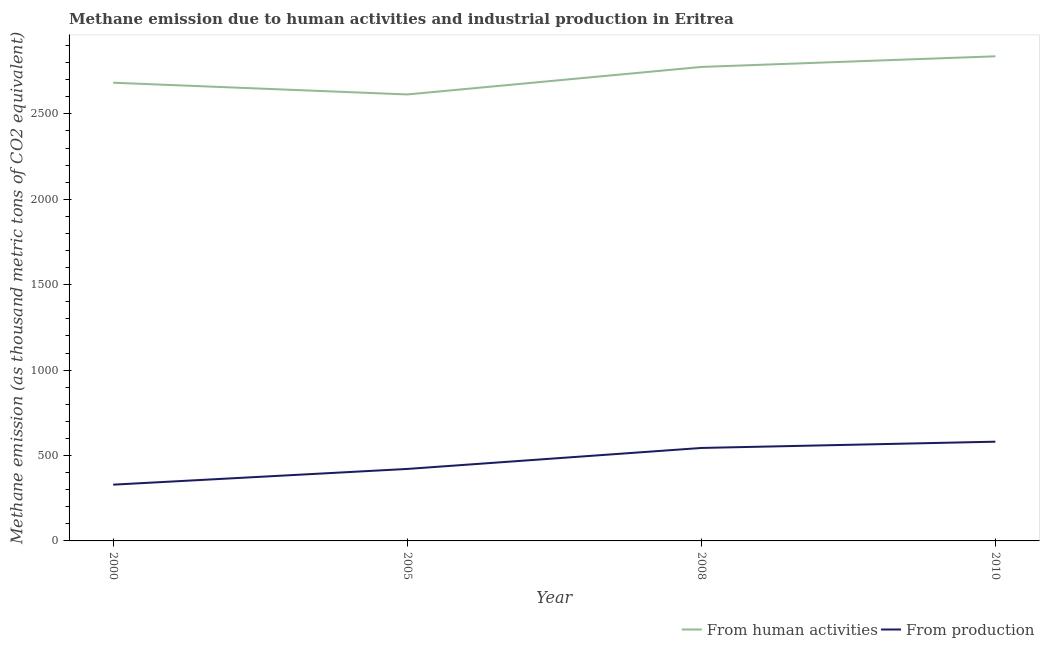How many different coloured lines are there?
Your answer should be compact. 2. Is the number of lines equal to the number of legend labels?
Your answer should be compact. Yes. What is the amount of emissions from human activities in 2010?
Give a very brief answer. 2837. Across all years, what is the maximum amount of emissions from human activities?
Keep it short and to the point. 2837. Across all years, what is the minimum amount of emissions from human activities?
Your answer should be compact. 2613.6. In which year was the amount of emissions from human activities maximum?
Provide a short and direct response. 2010. What is the total amount of emissions from human activities in the graph?
Provide a succinct answer. 1.09e+04. What is the difference between the amount of emissions generated from industries in 2005 and that in 2010?
Make the answer very short. -159.5. What is the difference between the amount of emissions generated from industries in 2010 and the amount of emissions from human activities in 2008?
Your answer should be compact. -2193.8. What is the average amount of emissions generated from industries per year?
Provide a succinct answer. 468.98. In the year 2008, what is the difference between the amount of emissions from human activities and amount of emissions generated from industries?
Provide a short and direct response. 2230.5. In how many years, is the amount of emissions from human activities greater than 1300 thousand metric tons?
Your response must be concise. 4. What is the ratio of the amount of emissions generated from industries in 2008 to that in 2010?
Keep it short and to the point. 0.94. What is the difference between the highest and the second highest amount of emissions generated from industries?
Keep it short and to the point. 36.7. What is the difference between the highest and the lowest amount of emissions from human activities?
Give a very brief answer. 223.4. In how many years, is the amount of emissions from human activities greater than the average amount of emissions from human activities taken over all years?
Offer a very short reply. 2. Is the sum of the amount of emissions generated from industries in 2005 and 2008 greater than the maximum amount of emissions from human activities across all years?
Keep it short and to the point. No. Does the amount of emissions from human activities monotonically increase over the years?
Offer a terse response. No. Is the amount of emissions generated from industries strictly less than the amount of emissions from human activities over the years?
Give a very brief answer. Yes. Does the graph contain any zero values?
Offer a terse response. No. How many legend labels are there?
Ensure brevity in your answer.  2. What is the title of the graph?
Give a very brief answer. Methane emission due to human activities and industrial production in Eritrea. What is the label or title of the X-axis?
Give a very brief answer. Year. What is the label or title of the Y-axis?
Your answer should be very brief. Methane emission (as thousand metric tons of CO2 equivalent). What is the Methane emission (as thousand metric tons of CO2 equivalent) in From human activities in 2000?
Offer a very short reply. 2682.3. What is the Methane emission (as thousand metric tons of CO2 equivalent) in From production in 2000?
Your answer should be compact. 329.4. What is the Methane emission (as thousand metric tons of CO2 equivalent) of From human activities in 2005?
Provide a succinct answer. 2613.6. What is the Methane emission (as thousand metric tons of CO2 equivalent) in From production in 2005?
Ensure brevity in your answer.  421.4. What is the Methane emission (as thousand metric tons of CO2 equivalent) of From human activities in 2008?
Your answer should be compact. 2774.7. What is the Methane emission (as thousand metric tons of CO2 equivalent) of From production in 2008?
Give a very brief answer. 544.2. What is the Methane emission (as thousand metric tons of CO2 equivalent) in From human activities in 2010?
Give a very brief answer. 2837. What is the Methane emission (as thousand metric tons of CO2 equivalent) of From production in 2010?
Give a very brief answer. 580.9. Across all years, what is the maximum Methane emission (as thousand metric tons of CO2 equivalent) of From human activities?
Your response must be concise. 2837. Across all years, what is the maximum Methane emission (as thousand metric tons of CO2 equivalent) of From production?
Give a very brief answer. 580.9. Across all years, what is the minimum Methane emission (as thousand metric tons of CO2 equivalent) in From human activities?
Provide a succinct answer. 2613.6. Across all years, what is the minimum Methane emission (as thousand metric tons of CO2 equivalent) in From production?
Give a very brief answer. 329.4. What is the total Methane emission (as thousand metric tons of CO2 equivalent) of From human activities in the graph?
Make the answer very short. 1.09e+04. What is the total Methane emission (as thousand metric tons of CO2 equivalent) in From production in the graph?
Offer a very short reply. 1875.9. What is the difference between the Methane emission (as thousand metric tons of CO2 equivalent) of From human activities in 2000 and that in 2005?
Provide a short and direct response. 68.7. What is the difference between the Methane emission (as thousand metric tons of CO2 equivalent) in From production in 2000 and that in 2005?
Provide a short and direct response. -92. What is the difference between the Methane emission (as thousand metric tons of CO2 equivalent) of From human activities in 2000 and that in 2008?
Make the answer very short. -92.4. What is the difference between the Methane emission (as thousand metric tons of CO2 equivalent) of From production in 2000 and that in 2008?
Your answer should be compact. -214.8. What is the difference between the Methane emission (as thousand metric tons of CO2 equivalent) in From human activities in 2000 and that in 2010?
Make the answer very short. -154.7. What is the difference between the Methane emission (as thousand metric tons of CO2 equivalent) in From production in 2000 and that in 2010?
Your answer should be very brief. -251.5. What is the difference between the Methane emission (as thousand metric tons of CO2 equivalent) of From human activities in 2005 and that in 2008?
Make the answer very short. -161.1. What is the difference between the Methane emission (as thousand metric tons of CO2 equivalent) in From production in 2005 and that in 2008?
Keep it short and to the point. -122.8. What is the difference between the Methane emission (as thousand metric tons of CO2 equivalent) in From human activities in 2005 and that in 2010?
Give a very brief answer. -223.4. What is the difference between the Methane emission (as thousand metric tons of CO2 equivalent) of From production in 2005 and that in 2010?
Provide a succinct answer. -159.5. What is the difference between the Methane emission (as thousand metric tons of CO2 equivalent) of From human activities in 2008 and that in 2010?
Your response must be concise. -62.3. What is the difference between the Methane emission (as thousand metric tons of CO2 equivalent) in From production in 2008 and that in 2010?
Your response must be concise. -36.7. What is the difference between the Methane emission (as thousand metric tons of CO2 equivalent) of From human activities in 2000 and the Methane emission (as thousand metric tons of CO2 equivalent) of From production in 2005?
Offer a very short reply. 2260.9. What is the difference between the Methane emission (as thousand metric tons of CO2 equivalent) of From human activities in 2000 and the Methane emission (as thousand metric tons of CO2 equivalent) of From production in 2008?
Offer a very short reply. 2138.1. What is the difference between the Methane emission (as thousand metric tons of CO2 equivalent) of From human activities in 2000 and the Methane emission (as thousand metric tons of CO2 equivalent) of From production in 2010?
Your answer should be compact. 2101.4. What is the difference between the Methane emission (as thousand metric tons of CO2 equivalent) in From human activities in 2005 and the Methane emission (as thousand metric tons of CO2 equivalent) in From production in 2008?
Provide a succinct answer. 2069.4. What is the difference between the Methane emission (as thousand metric tons of CO2 equivalent) in From human activities in 2005 and the Methane emission (as thousand metric tons of CO2 equivalent) in From production in 2010?
Make the answer very short. 2032.7. What is the difference between the Methane emission (as thousand metric tons of CO2 equivalent) of From human activities in 2008 and the Methane emission (as thousand metric tons of CO2 equivalent) of From production in 2010?
Ensure brevity in your answer.  2193.8. What is the average Methane emission (as thousand metric tons of CO2 equivalent) of From human activities per year?
Ensure brevity in your answer.  2726.9. What is the average Methane emission (as thousand metric tons of CO2 equivalent) in From production per year?
Keep it short and to the point. 468.98. In the year 2000, what is the difference between the Methane emission (as thousand metric tons of CO2 equivalent) in From human activities and Methane emission (as thousand metric tons of CO2 equivalent) in From production?
Provide a short and direct response. 2352.9. In the year 2005, what is the difference between the Methane emission (as thousand metric tons of CO2 equivalent) in From human activities and Methane emission (as thousand metric tons of CO2 equivalent) in From production?
Your answer should be very brief. 2192.2. In the year 2008, what is the difference between the Methane emission (as thousand metric tons of CO2 equivalent) of From human activities and Methane emission (as thousand metric tons of CO2 equivalent) of From production?
Provide a short and direct response. 2230.5. In the year 2010, what is the difference between the Methane emission (as thousand metric tons of CO2 equivalent) in From human activities and Methane emission (as thousand metric tons of CO2 equivalent) in From production?
Provide a short and direct response. 2256.1. What is the ratio of the Methane emission (as thousand metric tons of CO2 equivalent) in From human activities in 2000 to that in 2005?
Keep it short and to the point. 1.03. What is the ratio of the Methane emission (as thousand metric tons of CO2 equivalent) in From production in 2000 to that in 2005?
Provide a succinct answer. 0.78. What is the ratio of the Methane emission (as thousand metric tons of CO2 equivalent) in From human activities in 2000 to that in 2008?
Keep it short and to the point. 0.97. What is the ratio of the Methane emission (as thousand metric tons of CO2 equivalent) in From production in 2000 to that in 2008?
Your response must be concise. 0.61. What is the ratio of the Methane emission (as thousand metric tons of CO2 equivalent) of From human activities in 2000 to that in 2010?
Your answer should be compact. 0.95. What is the ratio of the Methane emission (as thousand metric tons of CO2 equivalent) in From production in 2000 to that in 2010?
Your answer should be very brief. 0.57. What is the ratio of the Methane emission (as thousand metric tons of CO2 equivalent) in From human activities in 2005 to that in 2008?
Your response must be concise. 0.94. What is the ratio of the Methane emission (as thousand metric tons of CO2 equivalent) of From production in 2005 to that in 2008?
Make the answer very short. 0.77. What is the ratio of the Methane emission (as thousand metric tons of CO2 equivalent) of From human activities in 2005 to that in 2010?
Your answer should be very brief. 0.92. What is the ratio of the Methane emission (as thousand metric tons of CO2 equivalent) of From production in 2005 to that in 2010?
Your response must be concise. 0.73. What is the ratio of the Methane emission (as thousand metric tons of CO2 equivalent) of From production in 2008 to that in 2010?
Provide a succinct answer. 0.94. What is the difference between the highest and the second highest Methane emission (as thousand metric tons of CO2 equivalent) in From human activities?
Provide a succinct answer. 62.3. What is the difference between the highest and the second highest Methane emission (as thousand metric tons of CO2 equivalent) in From production?
Provide a short and direct response. 36.7. What is the difference between the highest and the lowest Methane emission (as thousand metric tons of CO2 equivalent) in From human activities?
Make the answer very short. 223.4. What is the difference between the highest and the lowest Methane emission (as thousand metric tons of CO2 equivalent) of From production?
Make the answer very short. 251.5. 